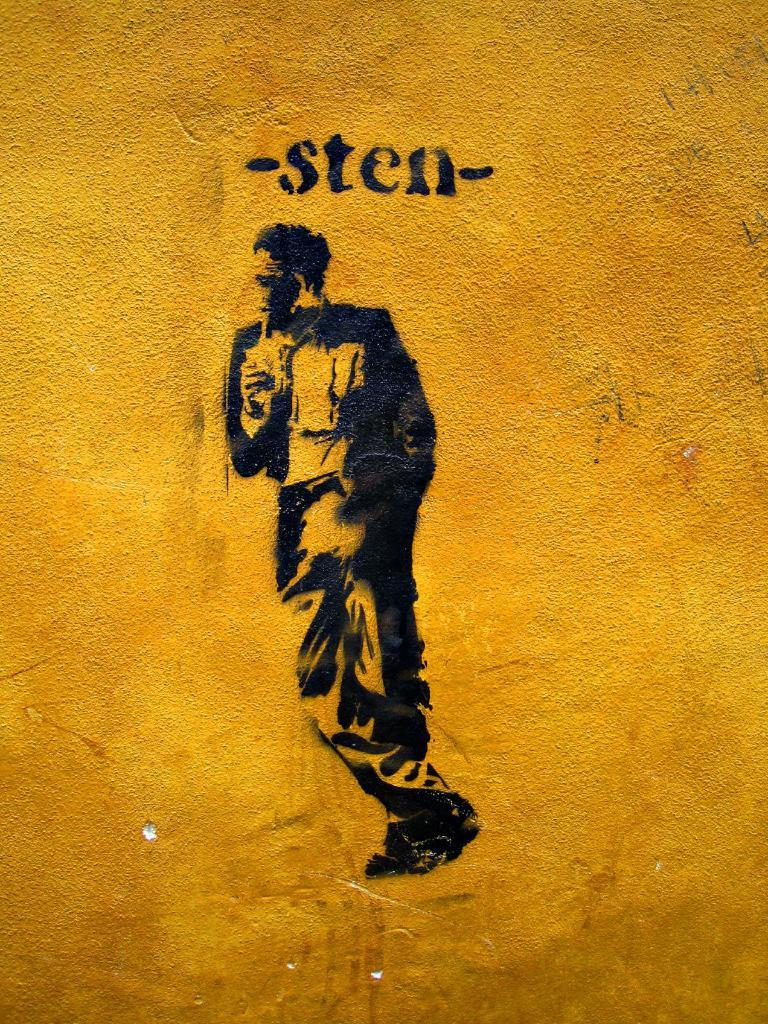<image>
Provide a brief description of the given image. a man painted in black on a textured gold background with the writing -sten- above him. 